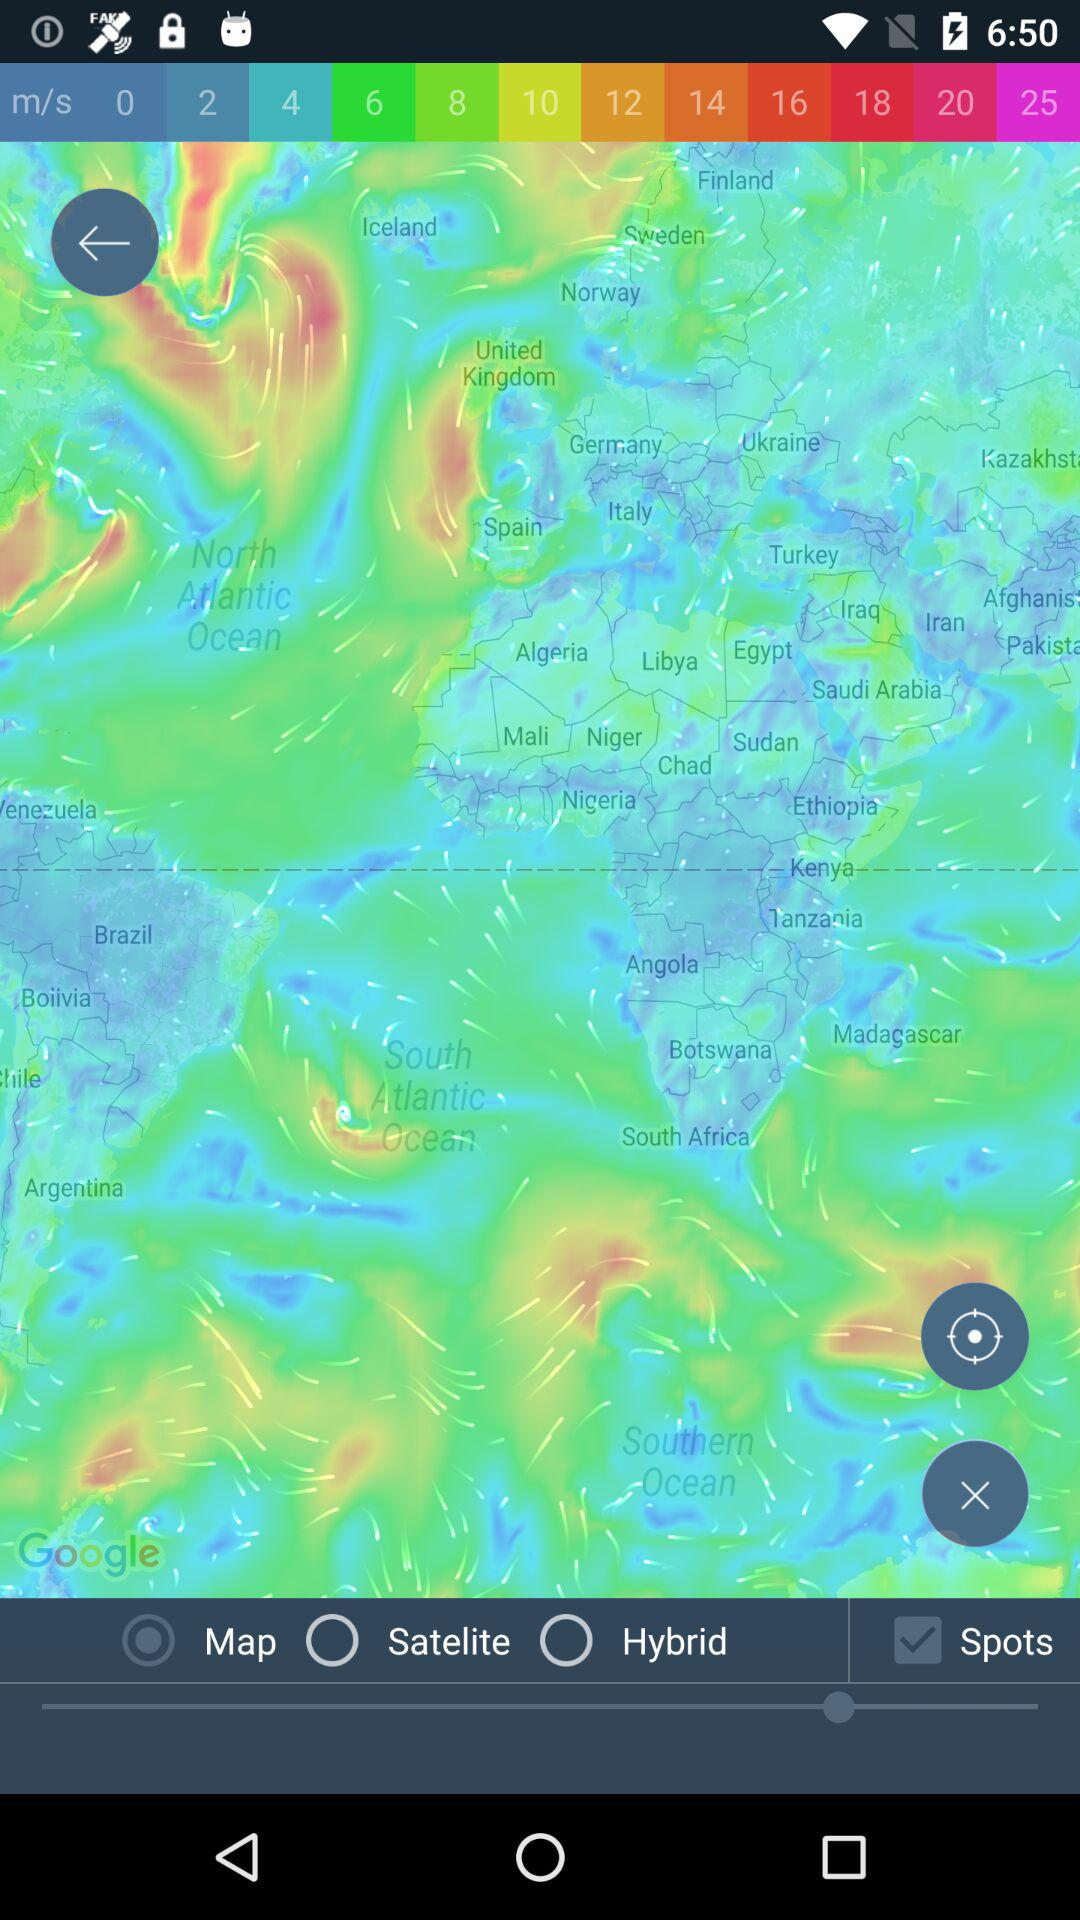Which radio button is selected? The selected radio button is "Map". 